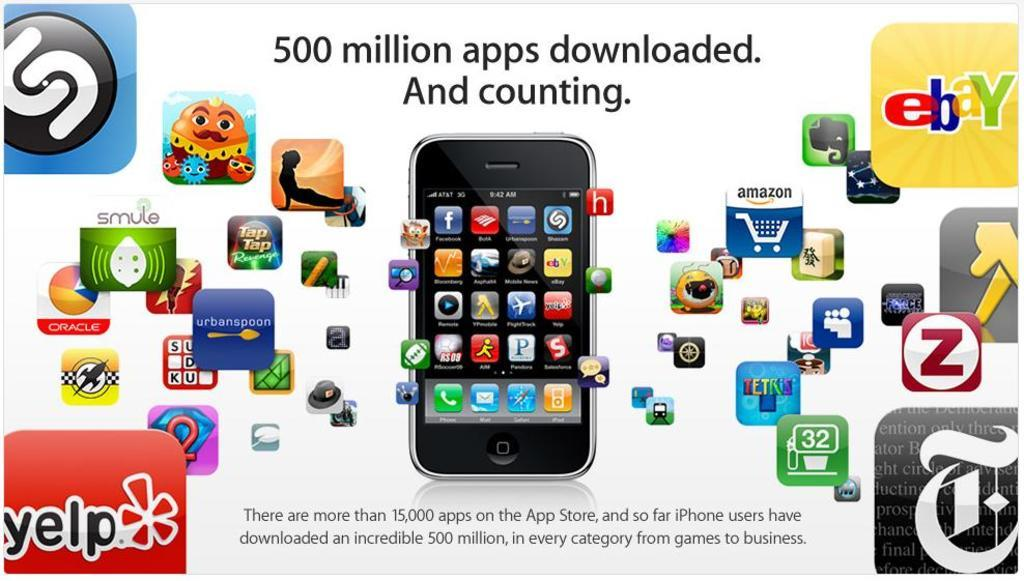<image>
Offer a succinct explanation of the picture presented. An ad with may logos displayed has ebay in one corner and Yelp in another. 